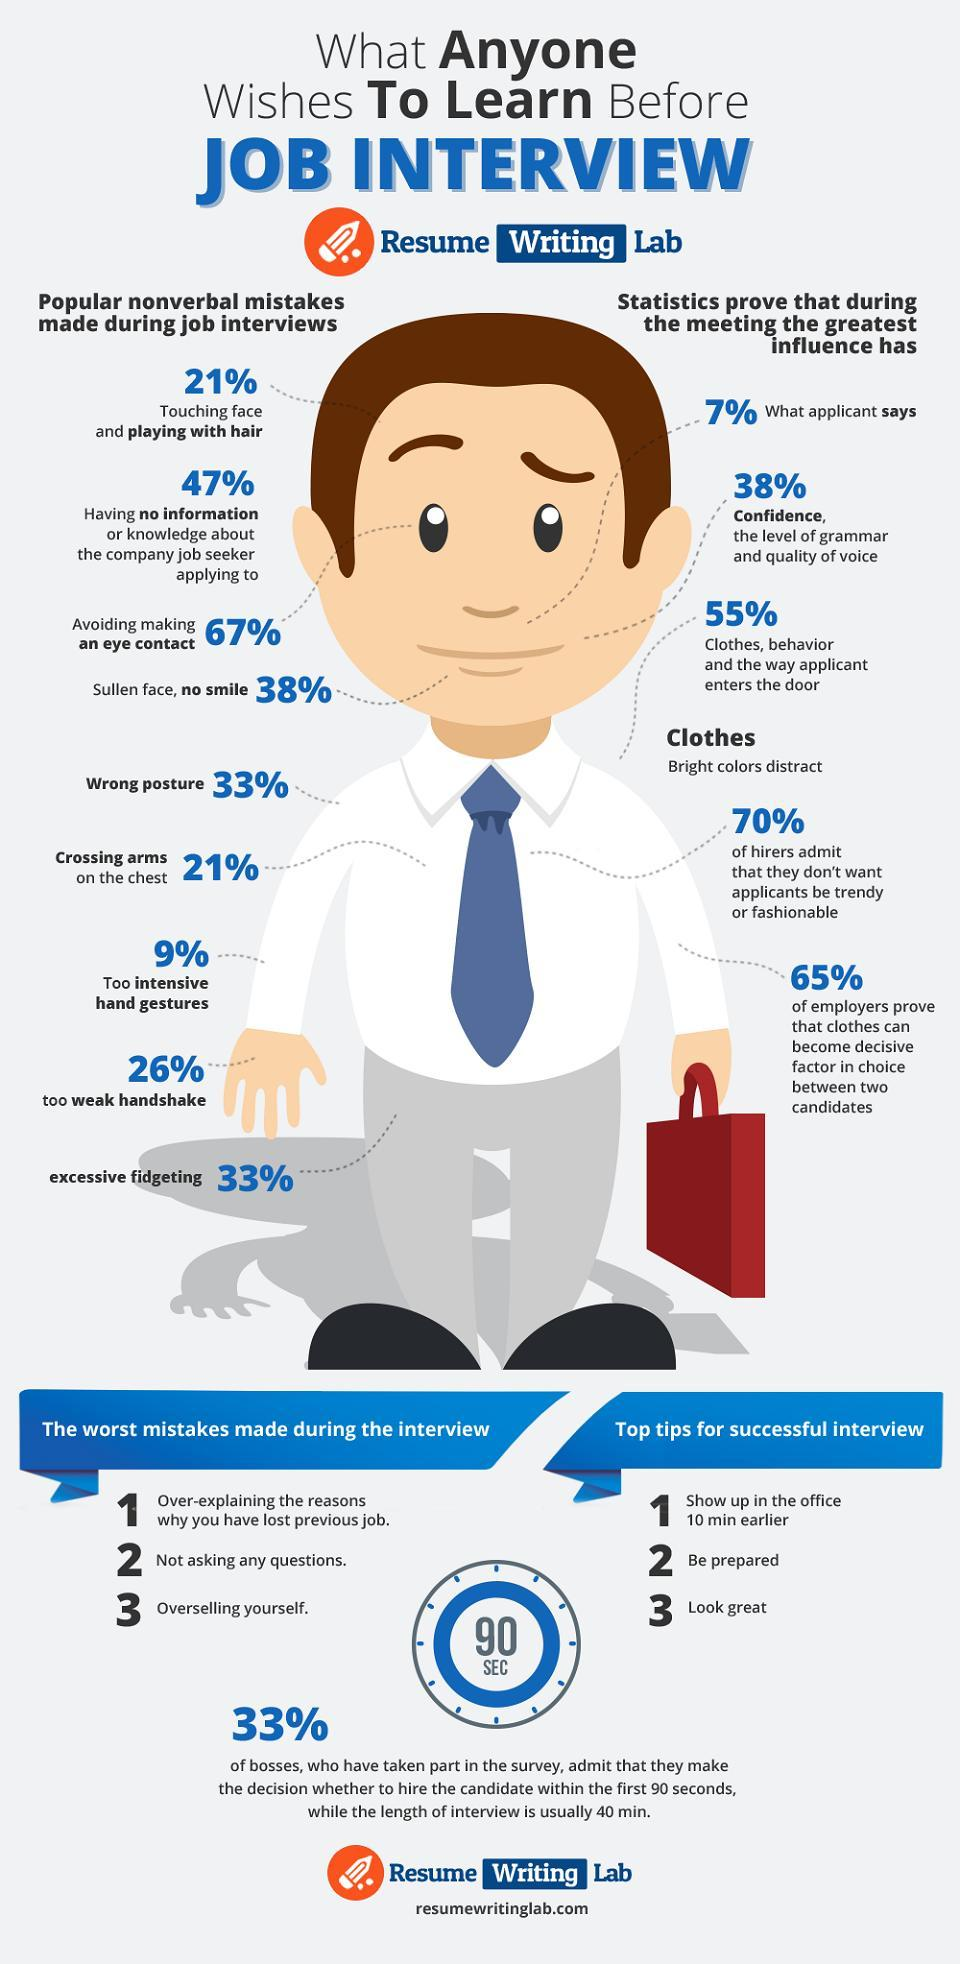How many non-verbal mistakes are listed?
Answer the question with a short phrase. 9 How many points are listed under clothes ? 2 What is the percentage of people who play with hair or cross their arms? 21% Which score the highest percentage in nonverbal mistakes weak handshake, wrong posture or no smile ? No smile 